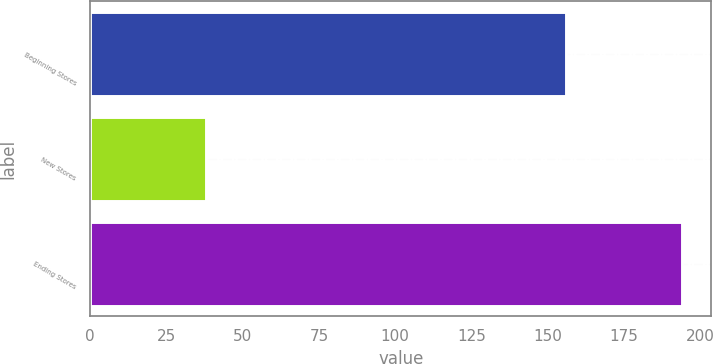<chart> <loc_0><loc_0><loc_500><loc_500><bar_chart><fcel>Beginning Stores<fcel>New Stores<fcel>Ending Stores<nl><fcel>156<fcel>38<fcel>194<nl></chart> 